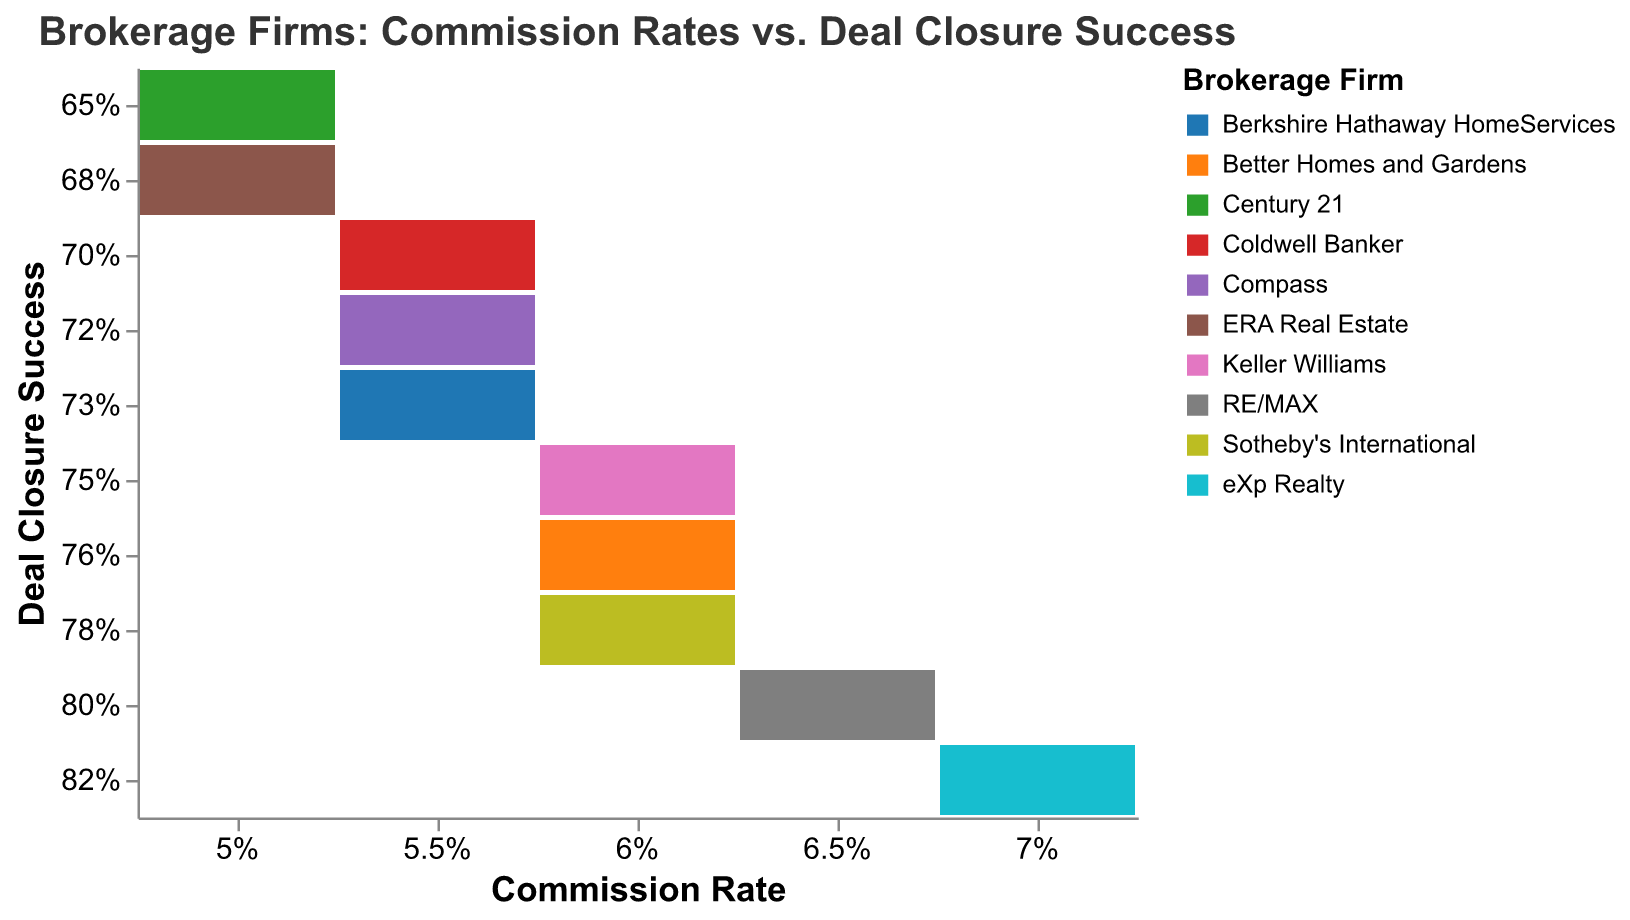How many brokerage firms are displayed in the mosaic plot? Count the number of unique colors or legends representing different brokerage firms in the plot.
Answer: 10 Which brokerage firm has the highest commission rate? Identify the firm corresponding to the highest column in the x-axis, which is 7%.
Answer: eXp Realty What is the deal closure success rate of Coldwell Banker? Locate Coldwell Banker on the plot and find the corresponding y-axis value.
Answer: 70% Which brokerage firm has both a 6% commission rate and a deal closure success rate of 75%? Find the intersection of x-axis (6%) and y-axis (75%) and check which firm's color and legend matches this intersection.
Answer: Keller Williams Which brokerage firm has the lowest deal closure success rate? Find the lowest value on the y-axis and check which firm's color and legend matches this value.
Answer: Century 21 How many firms have a commission rate of 5%? Count the number of data points along the column labeled 5% on the x-axis.
Answer: 2 Is there any brokerage firm with a commission rate of 6.5% and a deal closure success rate above 80%? Check the column labeled 6.5% on the x-axis and see if any firm in this column is above 80% on the y-axis.
Answer: No Which three brokerage firms have the highest deal closure success rates? Identify the top three points on the y-axis and check which firms’ colors and legends correspond to those points.
Answer: eXp Realty, RE/MAX, Sotheby's International What is the difference in deal closure success rate between Better Homes and Gardens and Century 21? Compare the success rates on the y-axis of Better Homes and Gardens (76%) and Century 21 (65%), and compute the difference.
Answer: 11% Which brokerage firms have a commission rate of 5.5%? Identify the points along the column labeled 5.5% on the x-axis and list the firms corresponding to those points.
Answer: Coldwell Banker, Compass, Berkshire Hathaway HomeServices 